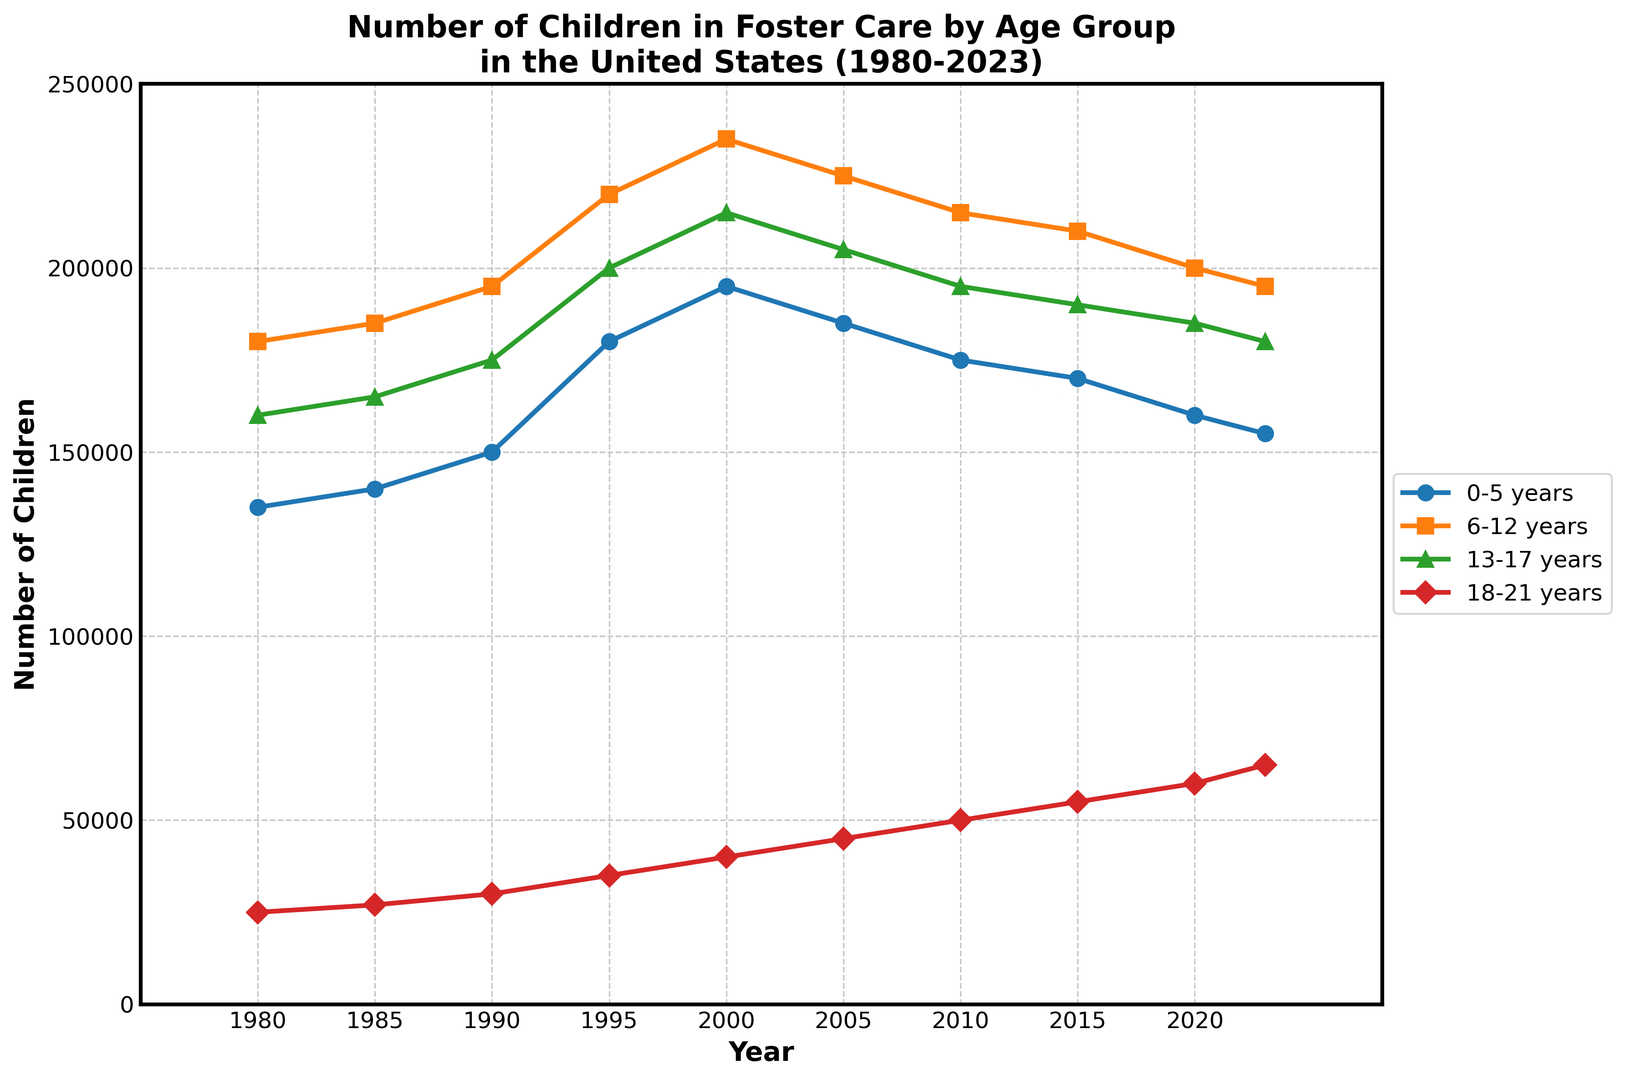What age group had the highest number of children in foster care in 2000? To find the answer, look at the data points for the year 2000 and identify which age group had the highest value. The 6-12 years age group had the highest number with 235,000 children.
Answer: 6-12 years How did the number of children aged 0-5 in foster care change from 1980 to 2023? To determine the change, subtract the number of children aged 0-5 in 1980 from the number in 2023. The number decreased from 135,000 to 155,000. Thus, the change is 155,000 - 135,000 = 20,000.
Answer: Increased by 20,000 During which year did the 18-21 years age group see the highest increase in the number of children compared to the previous year? Look at the increase between consecutive years for the 18-21 years age group. The highest increase was between 2010 and 2015, where the number went from 50,000 to 55,000, an increase of 5,000.
Answer: 2015 Which age group had the least number of children in foster care in 1980, and how many were there? Examine the data points for 1980 and find the least amount among the age groups. The 18-21 years age group had the least number of children, with 25,000.
Answer: 18-21 years, 25,000 Compare the trends of the 6-12 years and 13-17 years age groups. Which one shows a more consistent trend over the years? To compare, visually observe the line plots of both age groups from 1980 to 2023. The 6-12 years age group shows a more consistent increasing trend, while the 13-17 years age group has more fluctuations.
Answer: 6-12 years What is the total number of children in foster care across all age groups in the year 1995? Add the number of children for each age group in 1995. That is 180,000 (0-5 years) + 220,000 (6-12 years) + 200,000 (13-17 years) + 35,000 (18-21 years) = 635,000.
Answer: 635,000 Which age group had the smallest decrease in the number of children in foster care from 2015 to 2023? Calculate the decrease for each age group between 2015 and 2023. The 6-12 years age group decreased from 210,000 to 195,000, which is the smallest decrease of 15,000.
Answer: 6-12 years Identify the year in which the number of children aged 13-17 in foster care peaked. Look at the data points for the 13-17 years age group to find the maximum value. The peak was in the year 2000 with 215,000 children.
Answer: 2000 